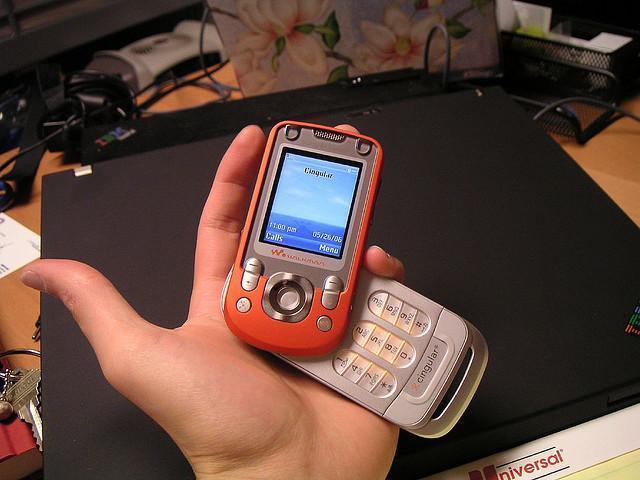How many cell phones can you see?
Give a very brief answer. 2. How many people are in the picture?
Give a very brief answer. 1. How many red cars are in this picture?
Give a very brief answer. 0. 